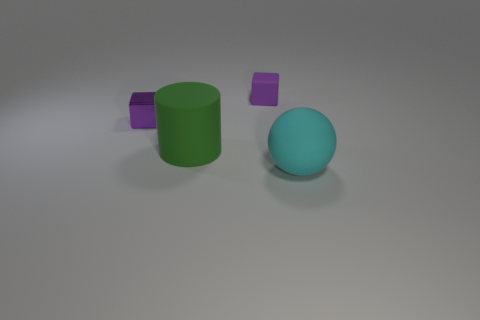Are there any other things that are the same shape as the large green thing?
Offer a very short reply. No. There is a big thing that is on the right side of the matte object behind the large matte object that is on the left side of the big rubber sphere; what is its material?
Provide a short and direct response. Rubber. Do the purple object that is to the left of the cylinder and the small matte object have the same size?
Ensure brevity in your answer.  Yes. There is a block that is to the right of the green cylinder; what is it made of?
Provide a succinct answer. Rubber. Are there more large rubber objects than tiny purple metallic things?
Your response must be concise. Yes. How many things are either purple things that are in front of the purple rubber block or small matte objects?
Provide a short and direct response. 2. How many things are on the right side of the small thing that is right of the tiny purple shiny thing?
Keep it short and to the point. 1. What is the size of the thing that is on the right side of the rubber thing behind the large object that is behind the cyan matte sphere?
Make the answer very short. Large. There is a cube on the right side of the green rubber thing; is its color the same as the large matte cylinder?
Give a very brief answer. No. What number of objects are either tiny matte blocks that are on the right side of the green matte cylinder or small purple rubber objects right of the purple shiny cube?
Ensure brevity in your answer.  1. 